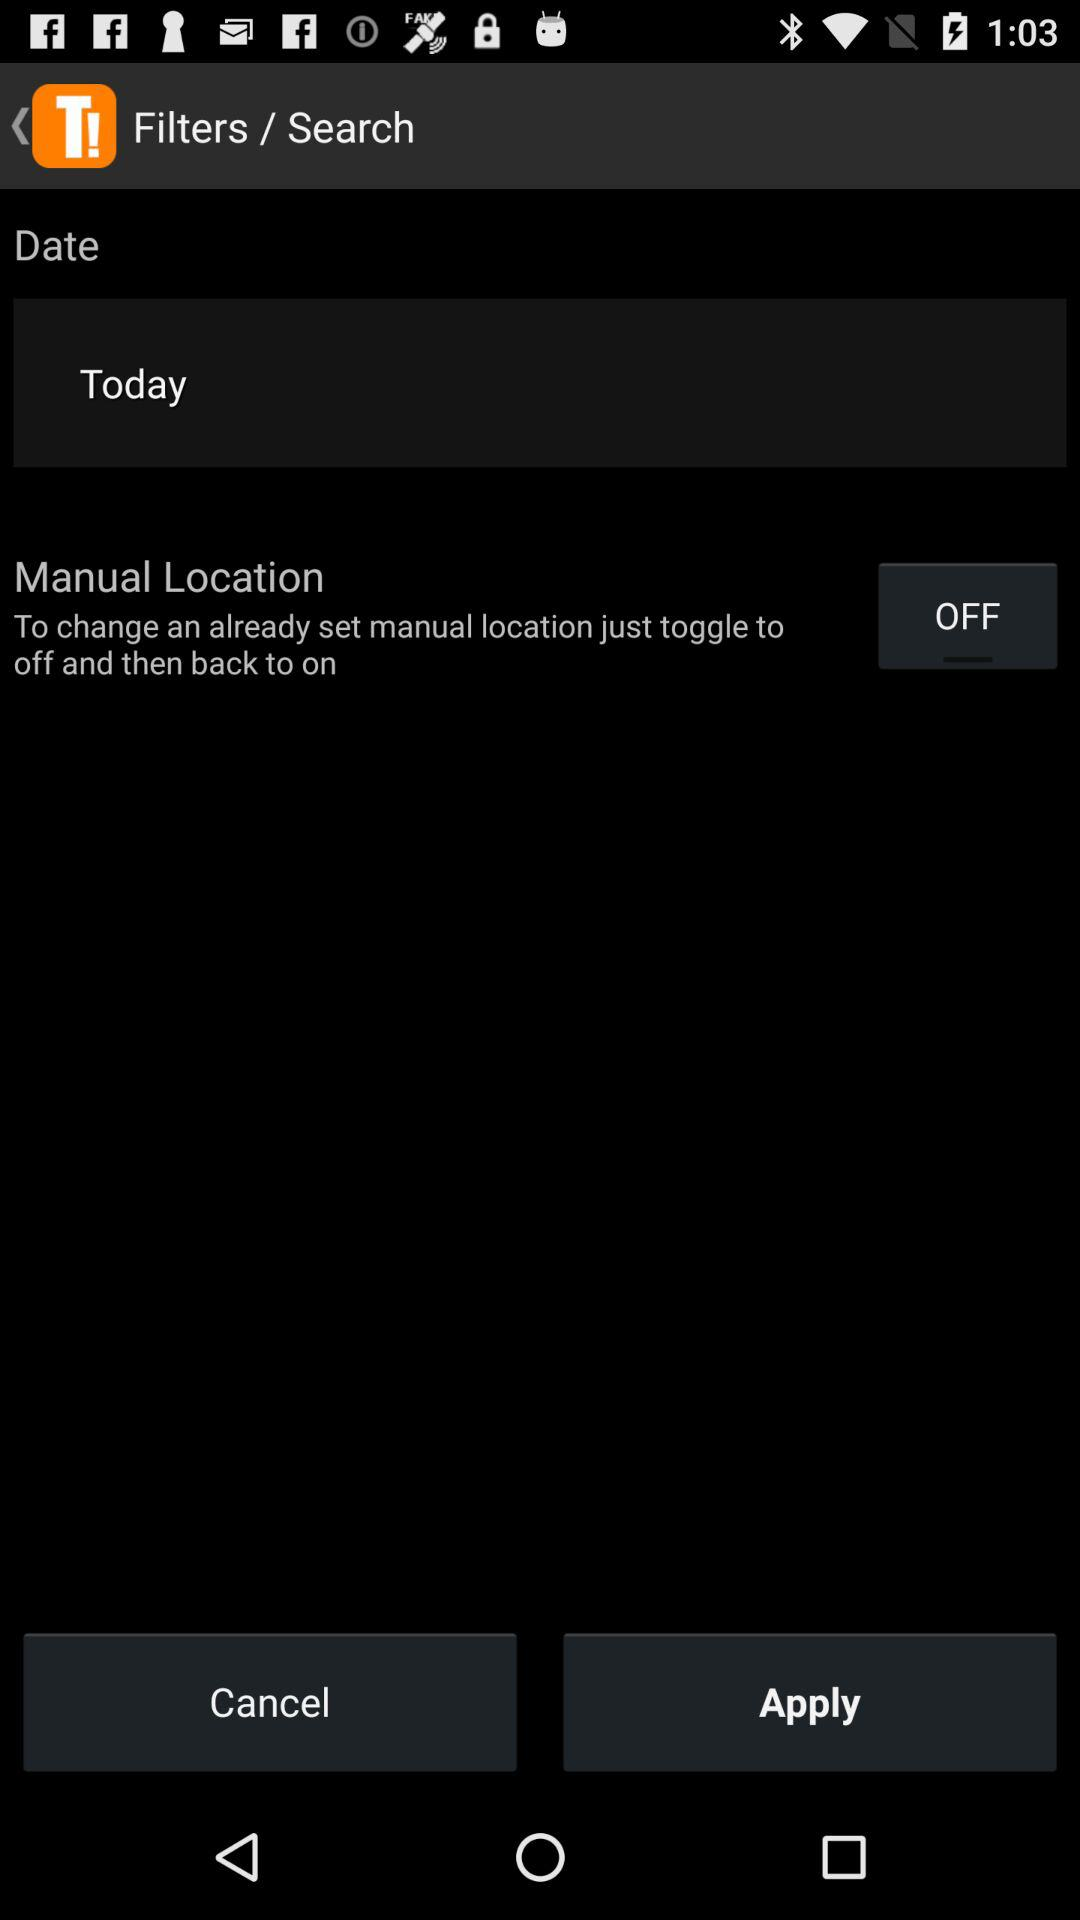What is the status of "Manual Location"? The status is "off". 